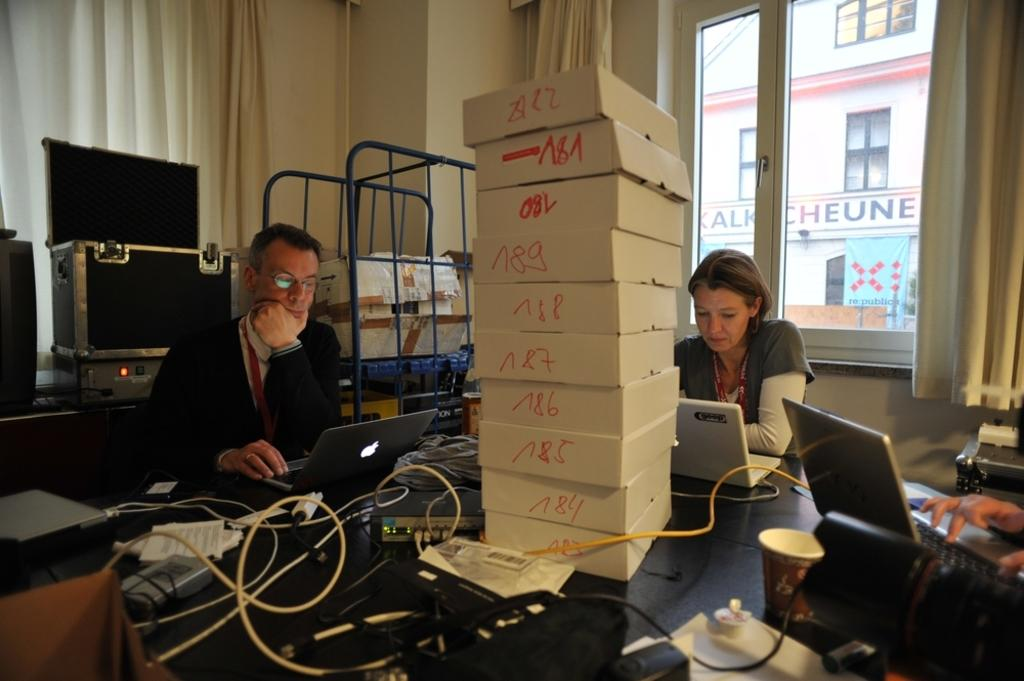<image>
Describe the image concisely. people next to some boxes with one that has the number 8 on it 